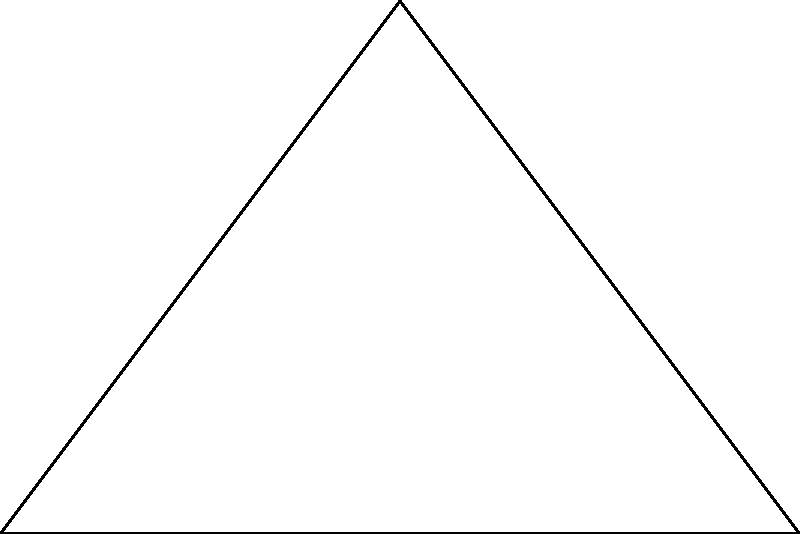A new LGBTQ+ health center is planned on a triangular plot of land. The plot has a base of 60 meters and an adjacent side of 40 meters, forming a right angle. What is the area of the triangular plot in square meters? Round your answer to the nearest whole number. To solve this problem, we'll use trigonometric formulas and the given information:

1) We have a right-angled triangle with:
   - Base (b) = 60 m
   - Height (h) = 40 m

2) The area of a triangle is given by the formula:
   $A = \frac{1}{2} \times base \times height$

3) Substituting the values:
   $A = \frac{1}{2} \times 60 \times 40$

4) Simplifying:
   $A = 30 \times 40 = 1200$

5) Therefore, the area of the triangular plot is 1200 square meters.

Note: We didn't need to use complex trigonometric formulas in this case because we were given the base and height directly. In more complex scenarios, we might need to use trigonometric ratios to find missing sides or angles.
Answer: 1200 sq m 